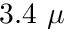Convert formula to latex. <formula><loc_0><loc_0><loc_500><loc_500>3 . 4 \mu</formula> 